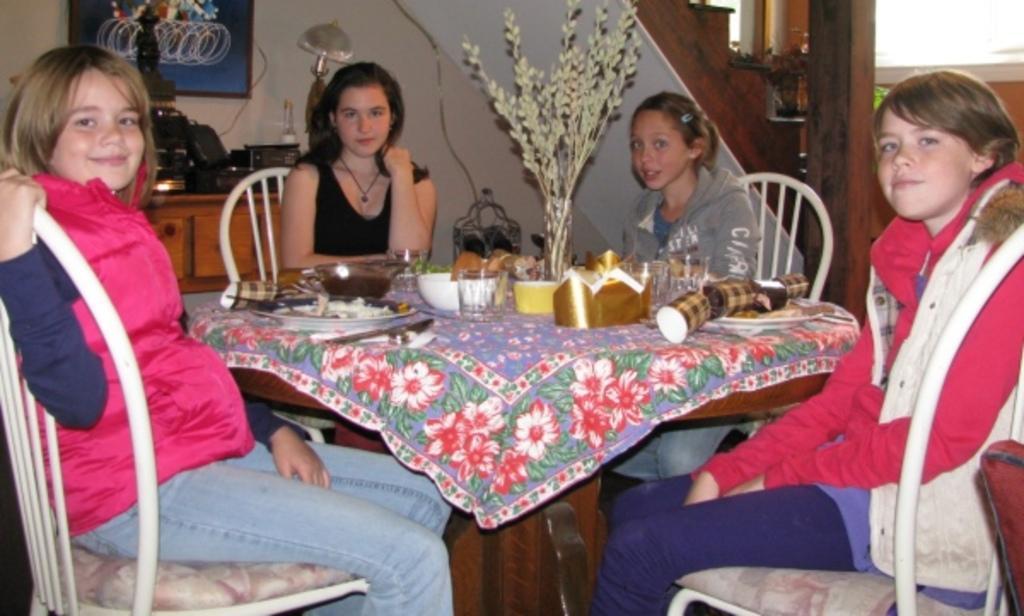Describe this image in one or two sentences. These 4 persons are sitting on a chair. In-front of this person there is a table, on a table there is a cloth, bowl, glass, plant, cups and plate. Far there is a furniture. Above the furniture there are electronic devices. A picture on wall. This is sculpture in black color. This is a lantern lamp. These are staircase. 